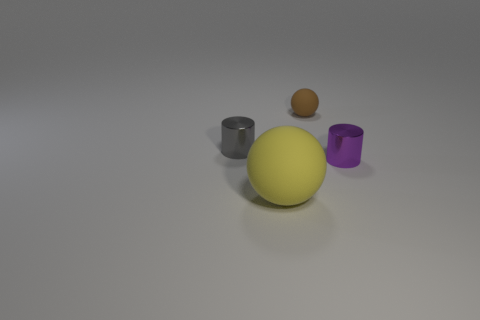Is there a large object?
Make the answer very short. Yes. What shape is the rubber object that is on the right side of the matte object in front of the small thing that is in front of the small gray metallic thing?
Your answer should be compact. Sphere. How many small metallic cylinders are left of the purple object?
Keep it short and to the point. 1. Is the material of the small cylinder on the left side of the small matte thing the same as the small purple object?
Your answer should be very brief. Yes. How many other objects are the same shape as the gray metal object?
Give a very brief answer. 1. How many yellow matte spheres are behind the matte ball that is in front of the matte thing on the right side of the yellow ball?
Give a very brief answer. 0. What is the color of the ball on the left side of the tiny rubber thing?
Make the answer very short. Yellow. Is the color of the ball that is to the right of the yellow object the same as the large matte sphere?
Your answer should be very brief. No. What is the size of the gray object that is the same shape as the tiny purple shiny object?
Offer a terse response. Small. Is there anything else that has the same size as the yellow ball?
Offer a very short reply. No. 